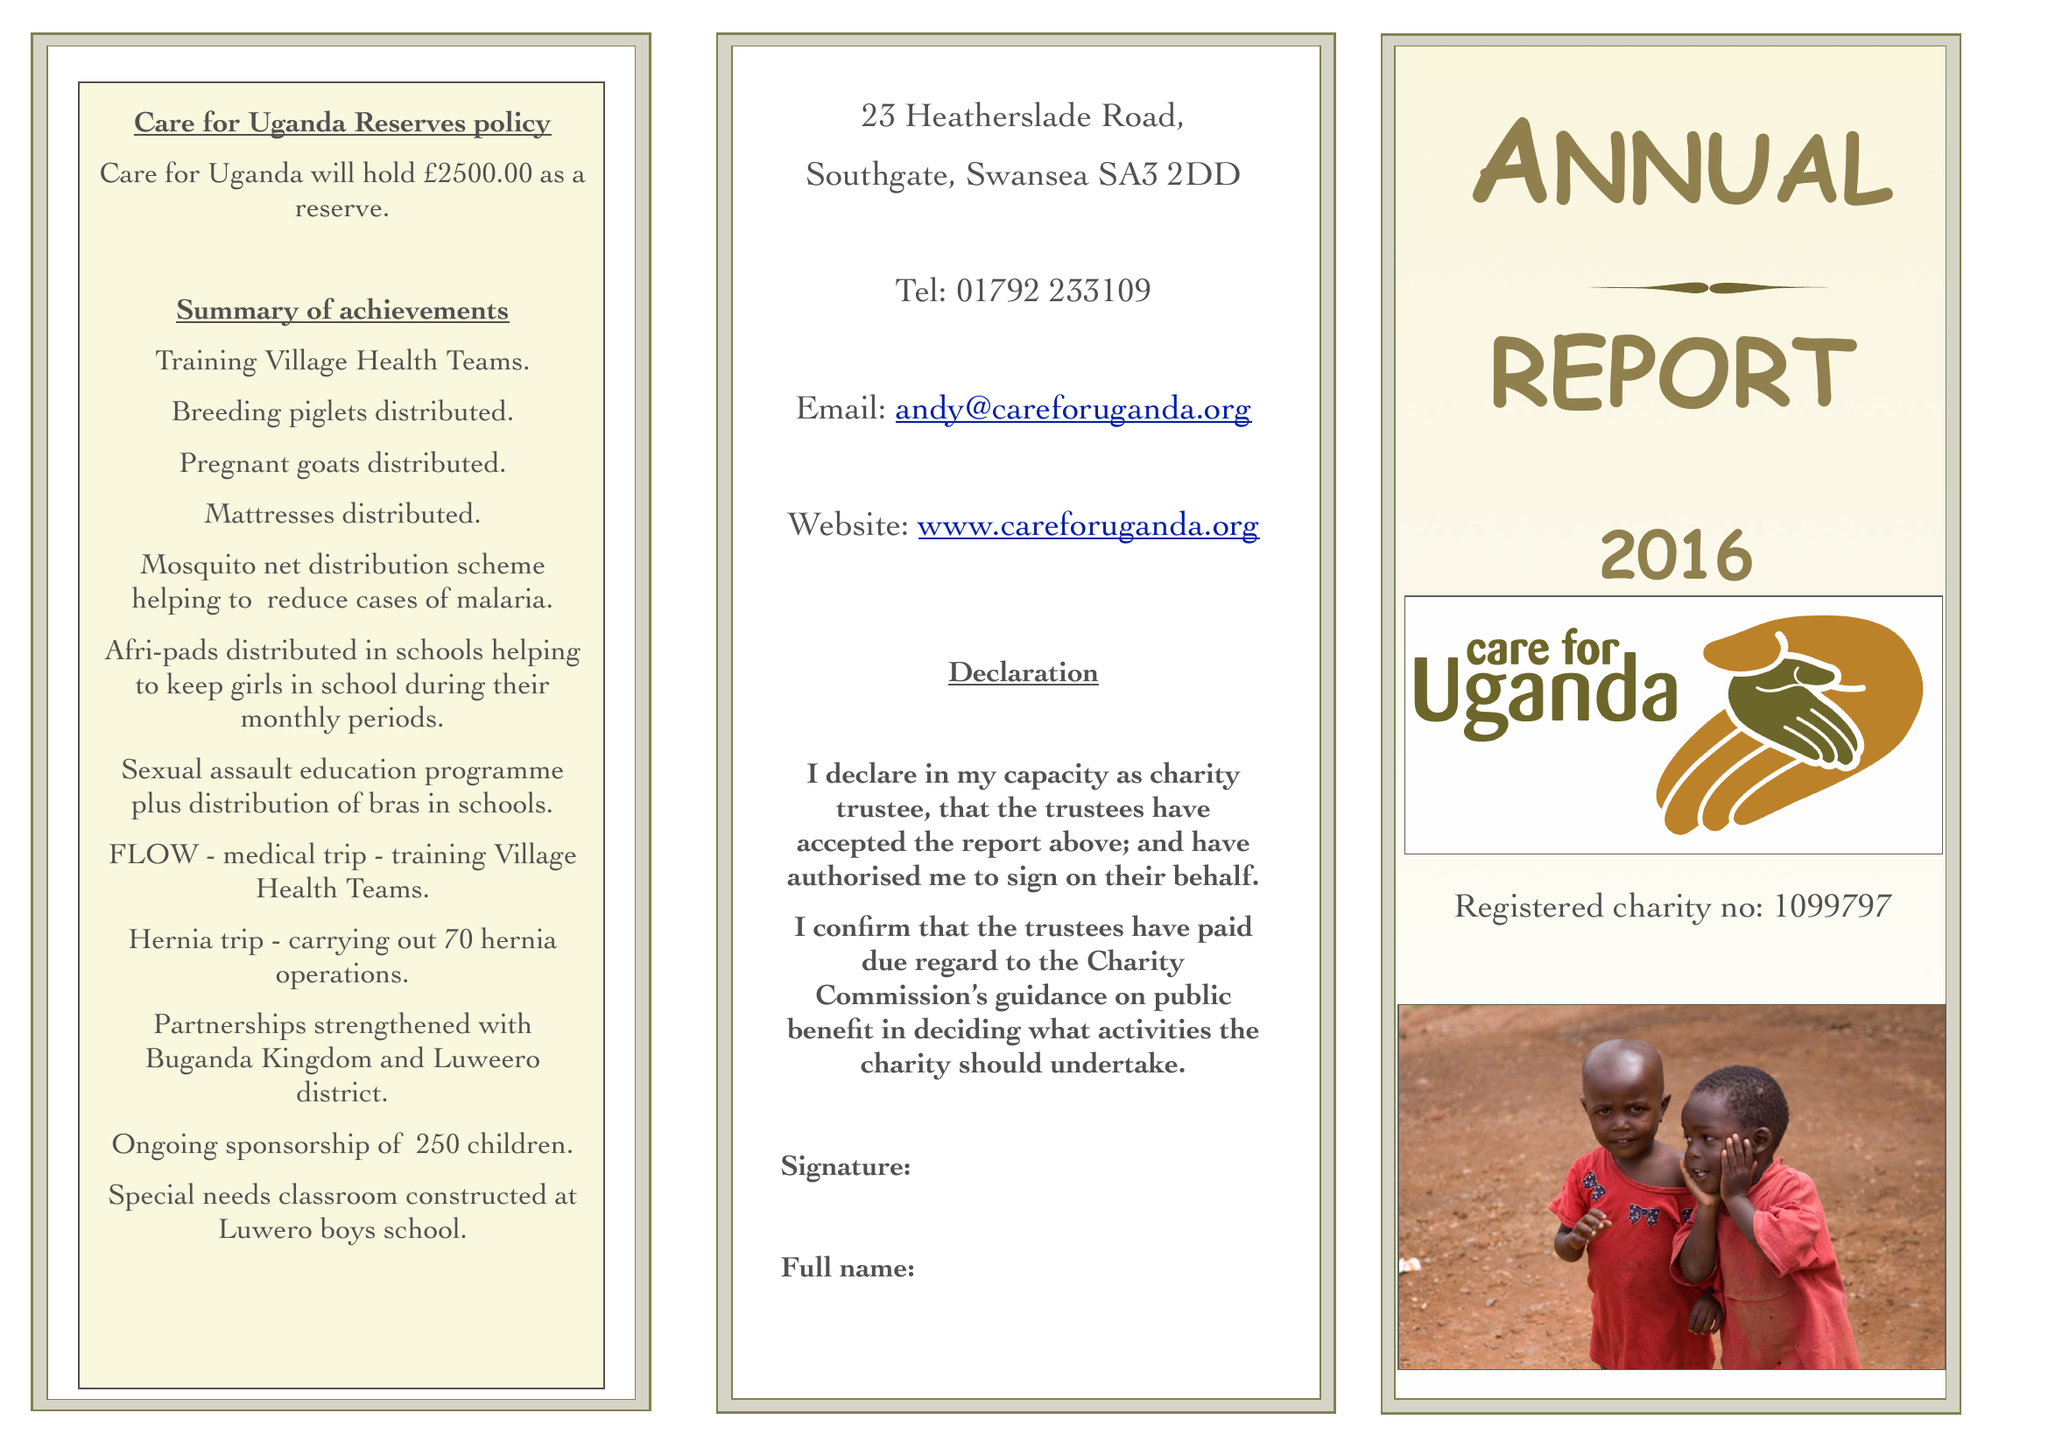What is the value for the report_date?
Answer the question using a single word or phrase. 2016-03-31 